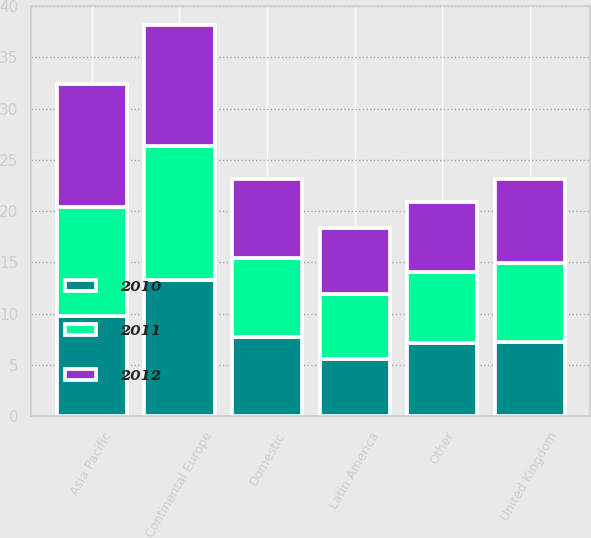Convert chart to OTSL. <chart><loc_0><loc_0><loc_500><loc_500><stacked_bar_chart><ecel><fcel>Domestic<fcel>United Kingdom<fcel>Continental Europe<fcel>Asia Pacific<fcel>Latin America<fcel>Other<nl><fcel>2012<fcel>7.7<fcel>8.2<fcel>11.8<fcel>12<fcel>6.5<fcel>6.8<nl><fcel>2011<fcel>7.7<fcel>7.7<fcel>13<fcel>10.6<fcel>6.3<fcel>7<nl><fcel>2010<fcel>7.7<fcel>7.2<fcel>13.3<fcel>9.8<fcel>5.6<fcel>7.1<nl></chart> 